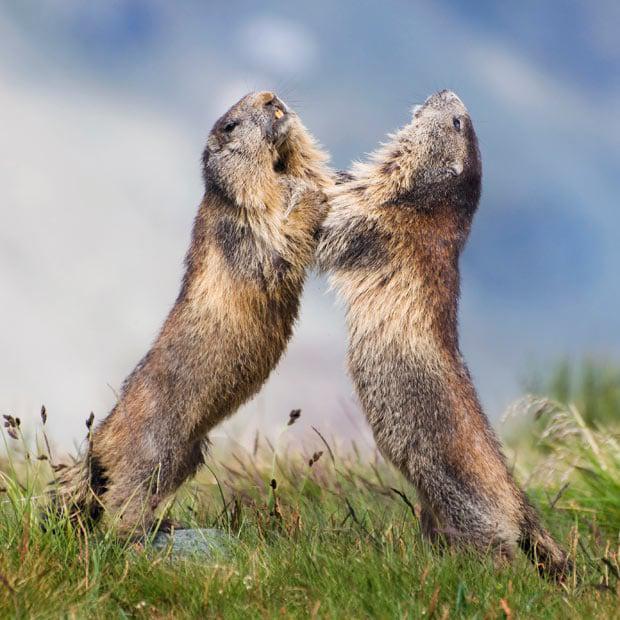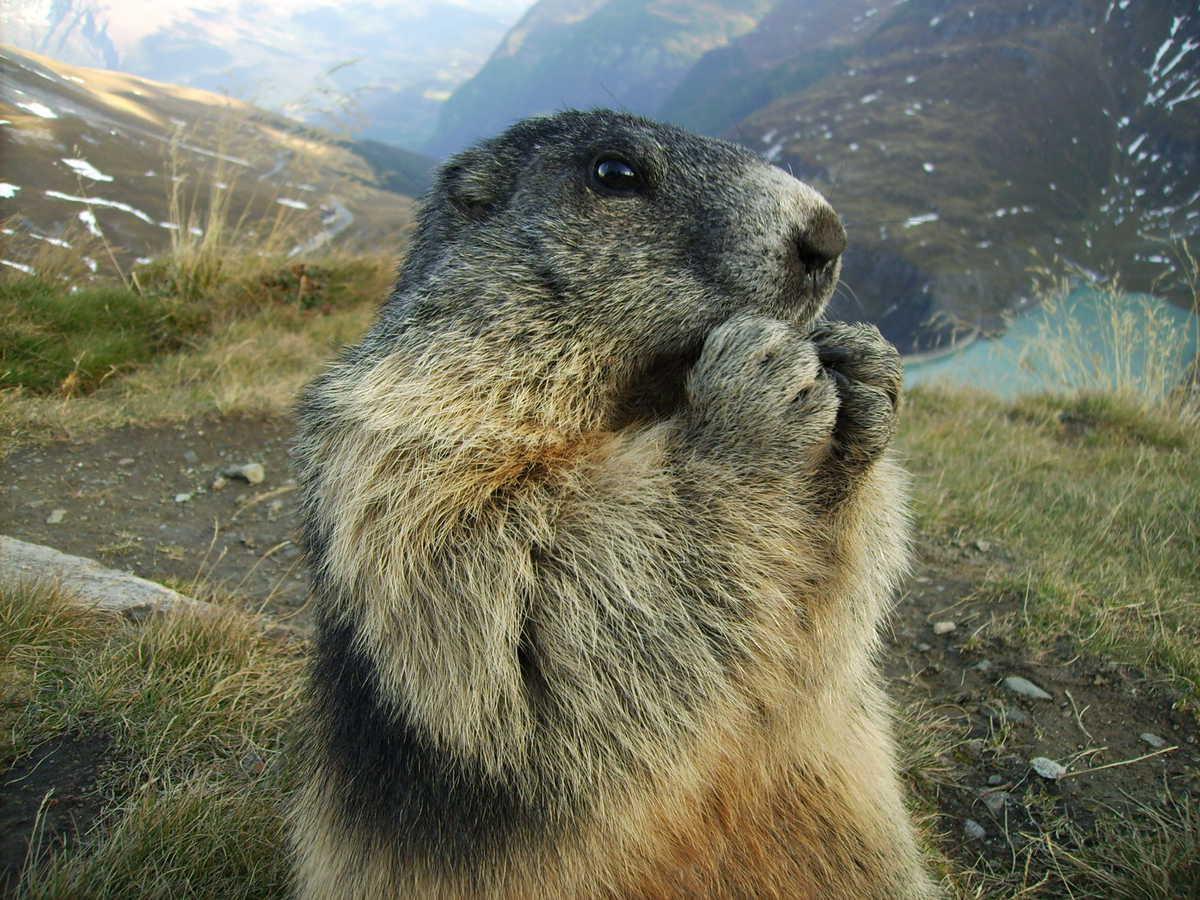The first image is the image on the left, the second image is the image on the right. Analyze the images presented: Is the assertion "There is more than one animal in at least one image." valid? Answer yes or no. Yes. 